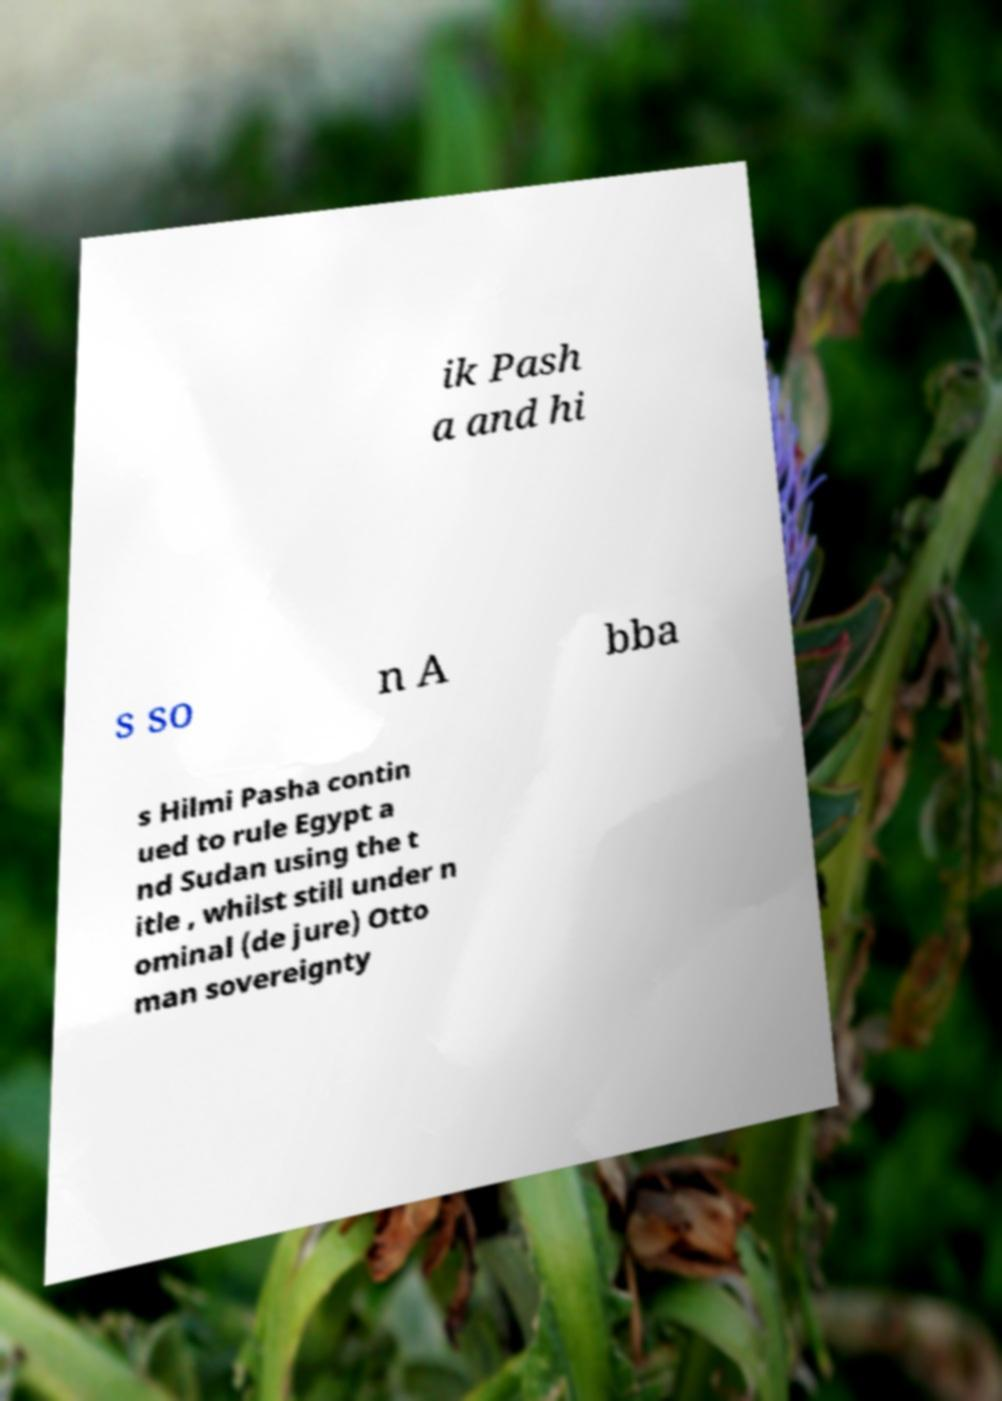Can you read and provide the text displayed in the image?This photo seems to have some interesting text. Can you extract and type it out for me? ik Pash a and hi s so n A bba s Hilmi Pasha contin ued to rule Egypt a nd Sudan using the t itle , whilst still under n ominal (de jure) Otto man sovereignty 